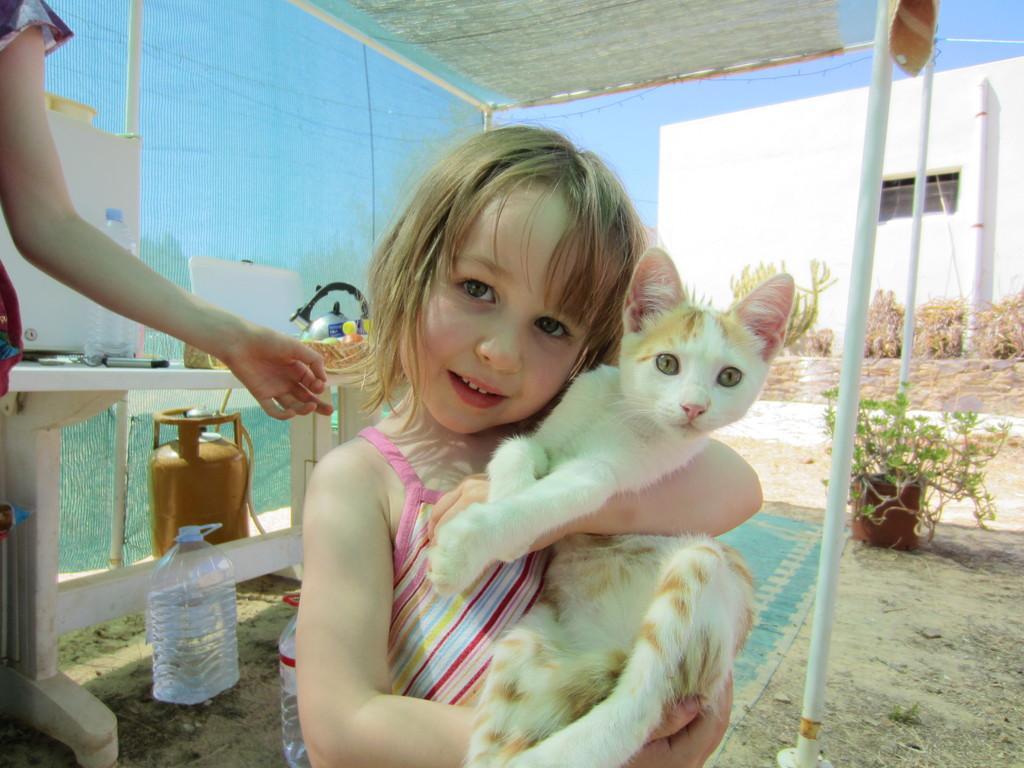Please provide a concise description of this image. There are two persons. This kid holding cat. We can see bottle,basket and things on the table. On the background we can see wall,plants. This is tent. We can see cylinder,bottles with water,plant,pot on the sand. 